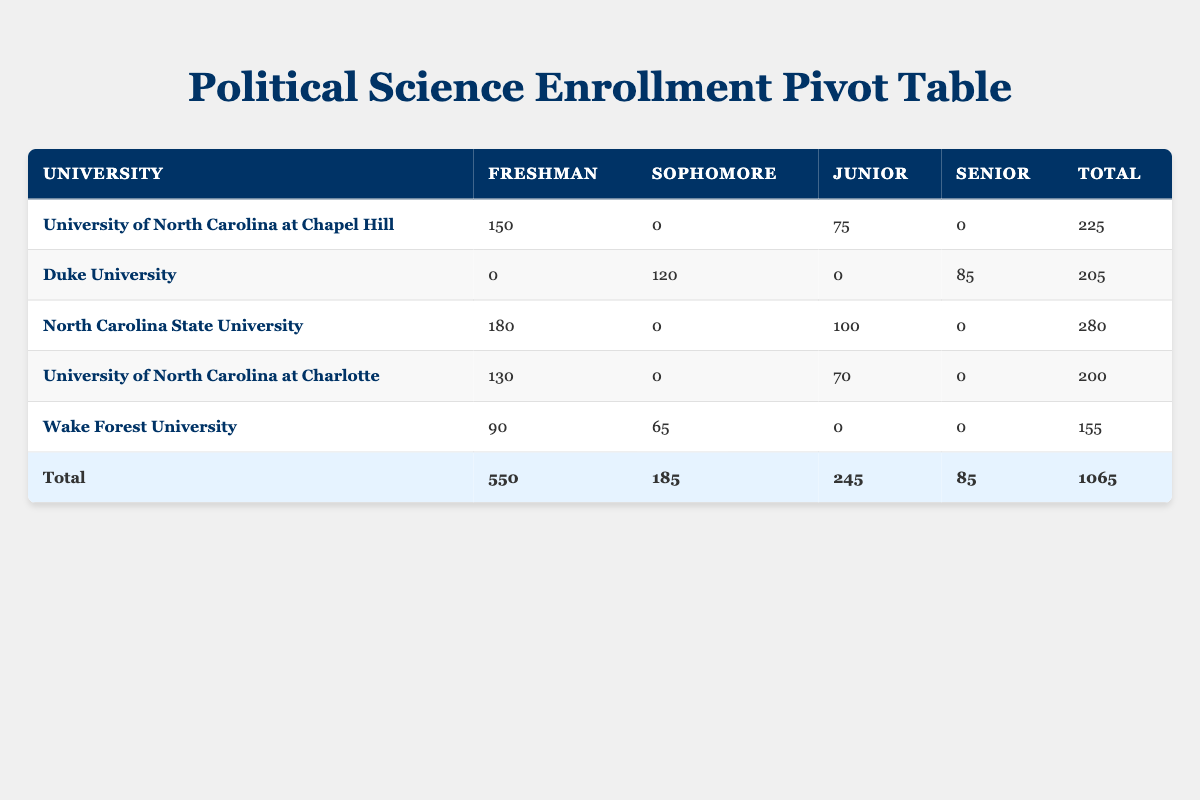What is the total enrollment for the University of North Carolina at Chapel Hill? The table shows that the enrollment count for the University of North Carolina at Chapel Hill is 150 for Freshman and 75 for Junior, therefore, total enrollment is 150 + 0 + 75 + 0 = 225.
Answer: 225 Which university has the highest number of freshman enrollments? By inspecting the Freshman column, North Carolina State University shows the highest number with 180 enrolled freshmen.
Answer: North Carolina State University Is there a Senior level course offered at the University of North Carolina at Charlotte? The Senior column for the University of North Carolina at Charlotte shows 0 enrollments, indicating there are no Senior level courses offered at this university.
Answer: No What is the combined total enrollment for sophomore courses across all universities? The table indicates that the combined total for sophomore courses consists of Duke University with 120 and Wake Forest University with 65, which sums up to 120 + 65 = 185.
Answer: 185 How many total students are enrolled in political science courses across all universities? To find the total, sum the values in the Total column: 225 (UNC Chapel Hill) + 205 (Duke) + 280 (NCSU) + 200 (UNC Charlotte) + 155 (Wake Forest) = 1065.
Answer: 1065 Which course has the minimum enrollment count? Looking at the EnrollmentCount values, POL 256: International Security at Wake Forest University has the minimum enrollment with 65 students.
Answer: POL 256: International Security Are there any courses with more than 120 students at Duke University? The enrollment numbers for Duke University are 120 (sophomore) and 85 (senior); only one course exceeds 120, which is the sophomore course.
Answer: Yes What is the average enrollment for junior level courses across all universities? The total enrollment for junior courses is 75 (UNC Chapel Hill) + 100 (NCSU) + 70 (UNC Charlotte) = 245. There are 3 entries for junior courses; thus, average enrollment = 245/3 = 81.67.
Answer: 81.67 Which university has the highest total enrollment count? By examining the Total column, North Carolina State University has the highest total with 280, compared to others: 225 (UNC Chapel Hill), 205 (Duke), 200 (UNC Charlotte), and 155 (Wake Forest).
Answer: North Carolina State University 